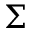Convert formula to latex. <formula><loc_0><loc_0><loc_500><loc_500>\Sigma</formula> 